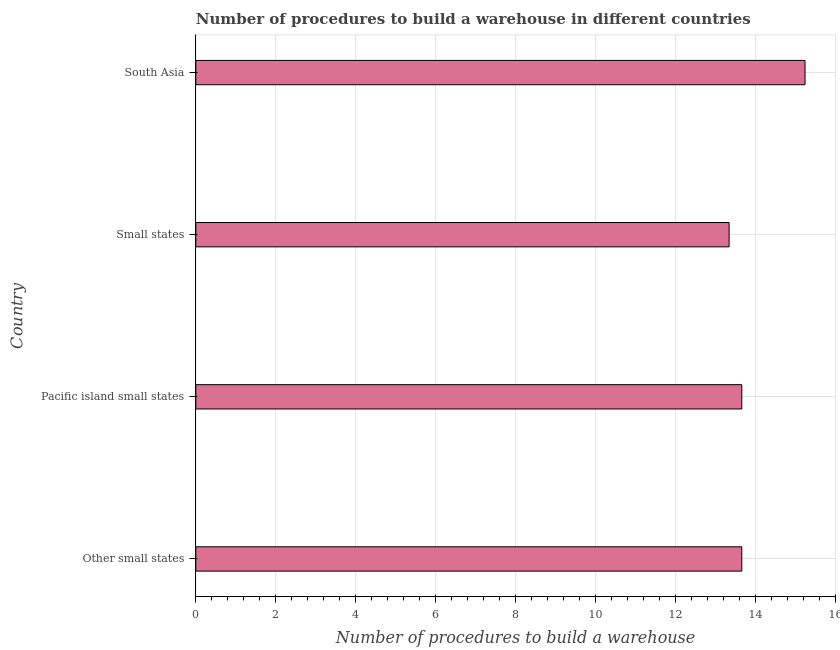Does the graph contain any zero values?
Make the answer very short. No. Does the graph contain grids?
Keep it short and to the point. Yes. What is the title of the graph?
Offer a very short reply. Number of procedures to build a warehouse in different countries. What is the label or title of the X-axis?
Provide a short and direct response. Number of procedures to build a warehouse. What is the label or title of the Y-axis?
Make the answer very short. Country. What is the number of procedures to build a warehouse in Small states?
Provide a succinct answer. 13.35. Across all countries, what is the maximum number of procedures to build a warehouse?
Your answer should be compact. 15.25. Across all countries, what is the minimum number of procedures to build a warehouse?
Ensure brevity in your answer.  13.35. In which country was the number of procedures to build a warehouse maximum?
Offer a terse response. South Asia. In which country was the number of procedures to build a warehouse minimum?
Ensure brevity in your answer.  Small states. What is the sum of the number of procedures to build a warehouse?
Ensure brevity in your answer.  55.93. What is the difference between the number of procedures to build a warehouse in Other small states and South Asia?
Make the answer very short. -1.58. What is the average number of procedures to build a warehouse per country?
Provide a short and direct response. 13.98. What is the median number of procedures to build a warehouse?
Provide a succinct answer. 13.67. What is the ratio of the number of procedures to build a warehouse in Pacific island small states to that in South Asia?
Provide a succinct answer. 0.9. Is the number of procedures to build a warehouse in Pacific island small states less than that in South Asia?
Provide a succinct answer. Yes. Is the difference between the number of procedures to build a warehouse in Pacific island small states and South Asia greater than the difference between any two countries?
Keep it short and to the point. No. What is the difference between the highest and the second highest number of procedures to build a warehouse?
Provide a succinct answer. 1.58. Is the sum of the number of procedures to build a warehouse in Other small states and Pacific island small states greater than the maximum number of procedures to build a warehouse across all countries?
Your answer should be very brief. Yes. What is the difference between the highest and the lowest number of procedures to build a warehouse?
Provide a succinct answer. 1.9. In how many countries, is the number of procedures to build a warehouse greater than the average number of procedures to build a warehouse taken over all countries?
Offer a terse response. 1. How many bars are there?
Make the answer very short. 4. How many countries are there in the graph?
Provide a succinct answer. 4. What is the Number of procedures to build a warehouse in Other small states?
Offer a very short reply. 13.67. What is the Number of procedures to build a warehouse in Pacific island small states?
Your answer should be very brief. 13.67. What is the Number of procedures to build a warehouse of Small states?
Your answer should be very brief. 13.35. What is the Number of procedures to build a warehouse of South Asia?
Your response must be concise. 15.25. What is the difference between the Number of procedures to build a warehouse in Other small states and Pacific island small states?
Your response must be concise. 0. What is the difference between the Number of procedures to build a warehouse in Other small states and Small states?
Keep it short and to the point. 0.32. What is the difference between the Number of procedures to build a warehouse in Other small states and South Asia?
Give a very brief answer. -1.58. What is the difference between the Number of procedures to build a warehouse in Pacific island small states and Small states?
Provide a short and direct response. 0.32. What is the difference between the Number of procedures to build a warehouse in Pacific island small states and South Asia?
Ensure brevity in your answer.  -1.58. What is the ratio of the Number of procedures to build a warehouse in Other small states to that in Pacific island small states?
Your answer should be compact. 1. What is the ratio of the Number of procedures to build a warehouse in Other small states to that in Small states?
Your answer should be compact. 1.02. What is the ratio of the Number of procedures to build a warehouse in Other small states to that in South Asia?
Ensure brevity in your answer.  0.9. What is the ratio of the Number of procedures to build a warehouse in Pacific island small states to that in South Asia?
Keep it short and to the point. 0.9. 